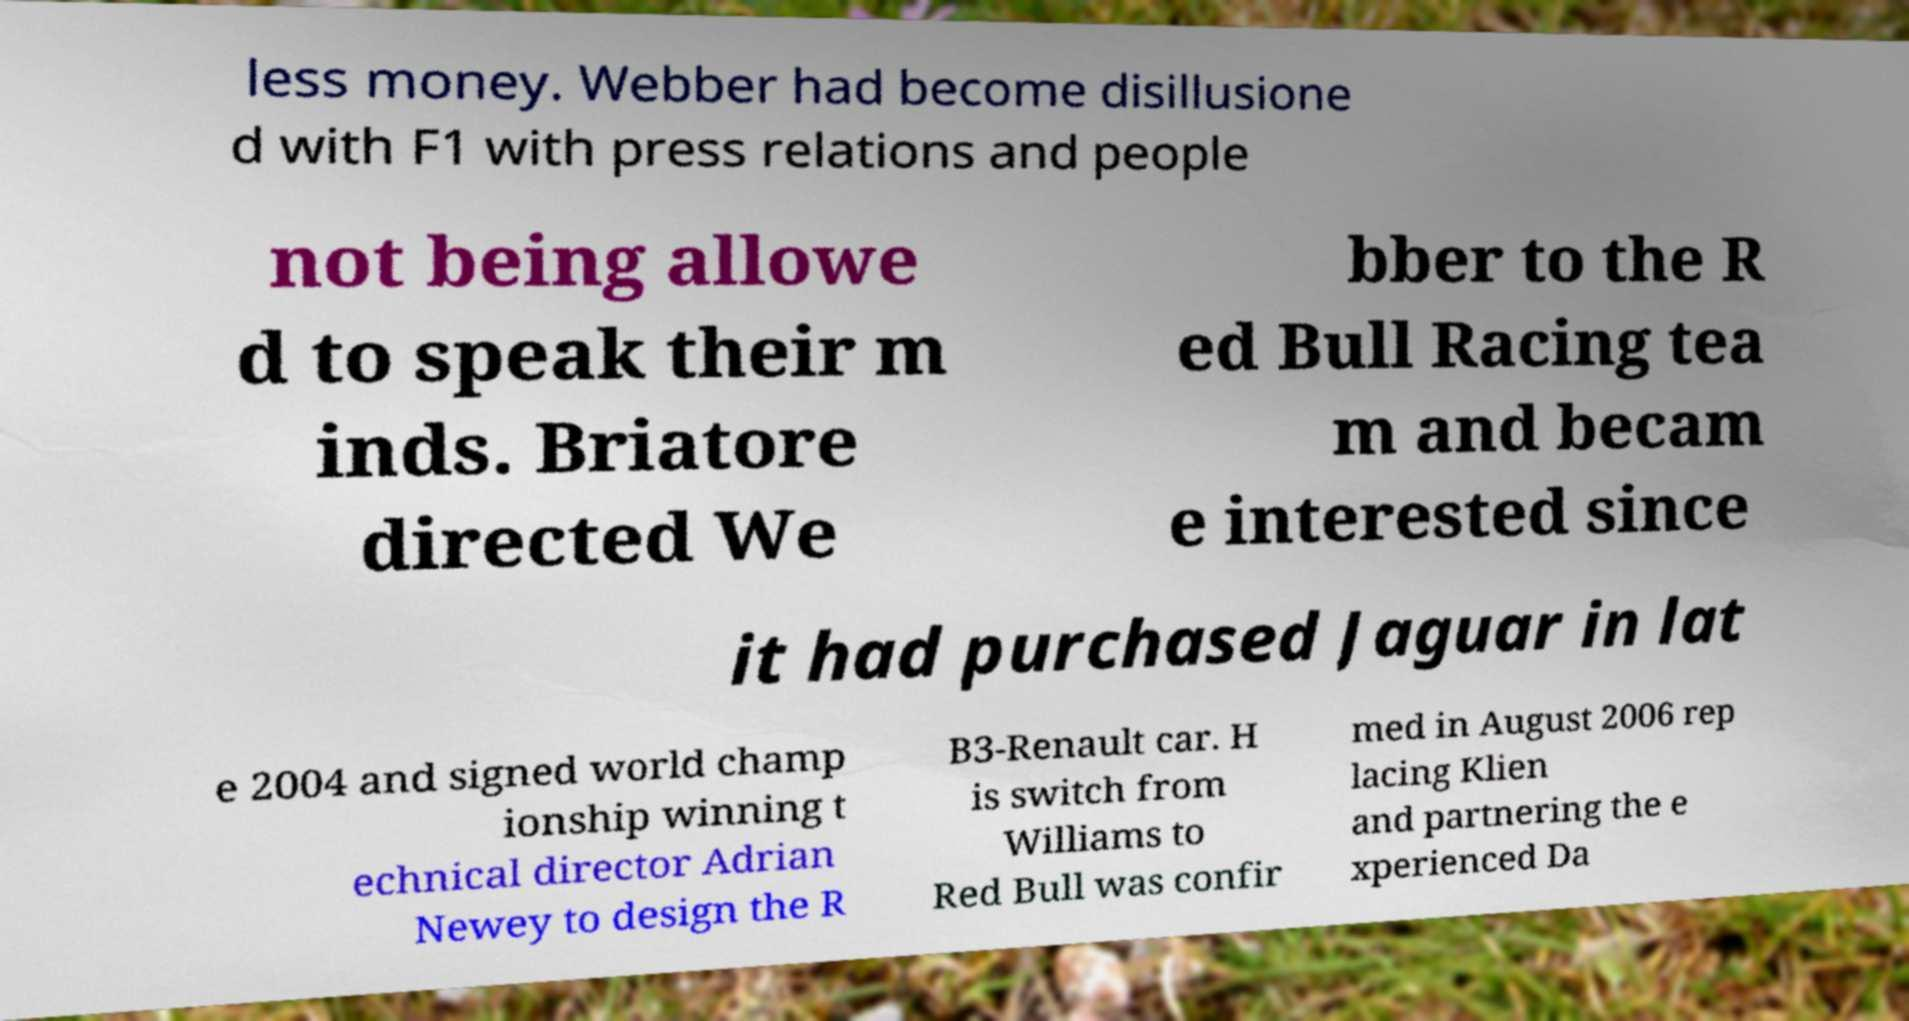For documentation purposes, I need the text within this image transcribed. Could you provide that? less money. Webber had become disillusione d with F1 with press relations and people not being allowe d to speak their m inds. Briatore directed We bber to the R ed Bull Racing tea m and becam e interested since it had purchased Jaguar in lat e 2004 and signed world champ ionship winning t echnical director Adrian Newey to design the R B3-Renault car. H is switch from Williams to Red Bull was confir med in August 2006 rep lacing Klien and partnering the e xperienced Da 